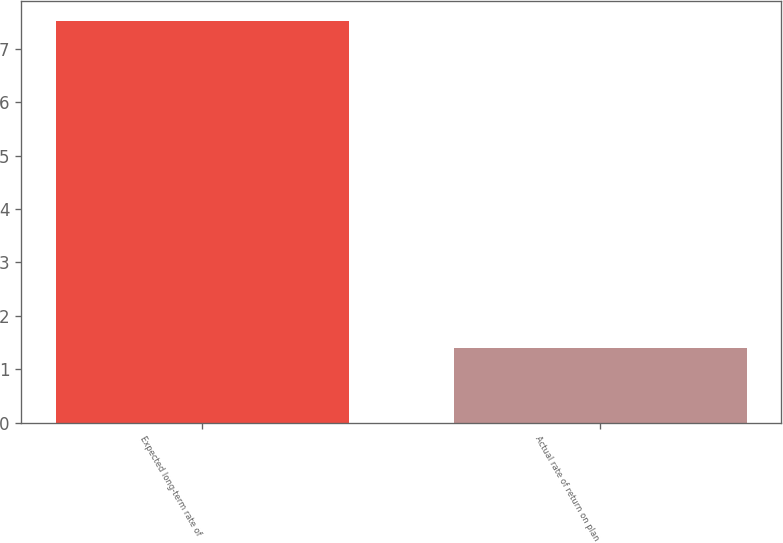Convert chart. <chart><loc_0><loc_0><loc_500><loc_500><bar_chart><fcel>Expected long-term rate of<fcel>Actual rate of return on plan<nl><fcel>7.52<fcel>1.4<nl></chart> 